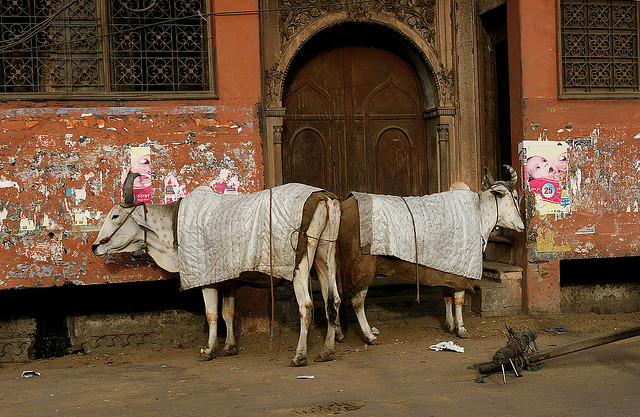Please extract the text content from this image. 25 